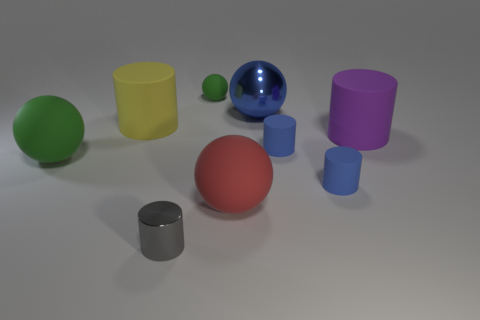There is a big object that is the same color as the tiny matte sphere; what is its shape? sphere 